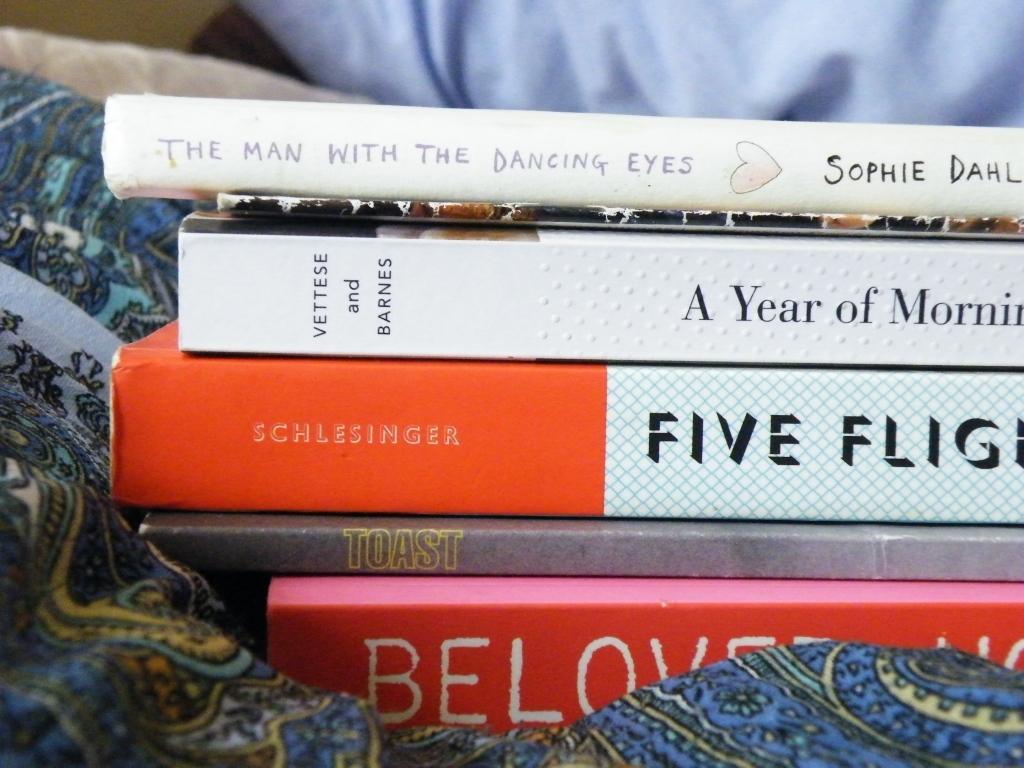Provide a one-sentence caption for the provided image. Five books stacked on top of each other, the top one says The Man with Dancing Eyes. 